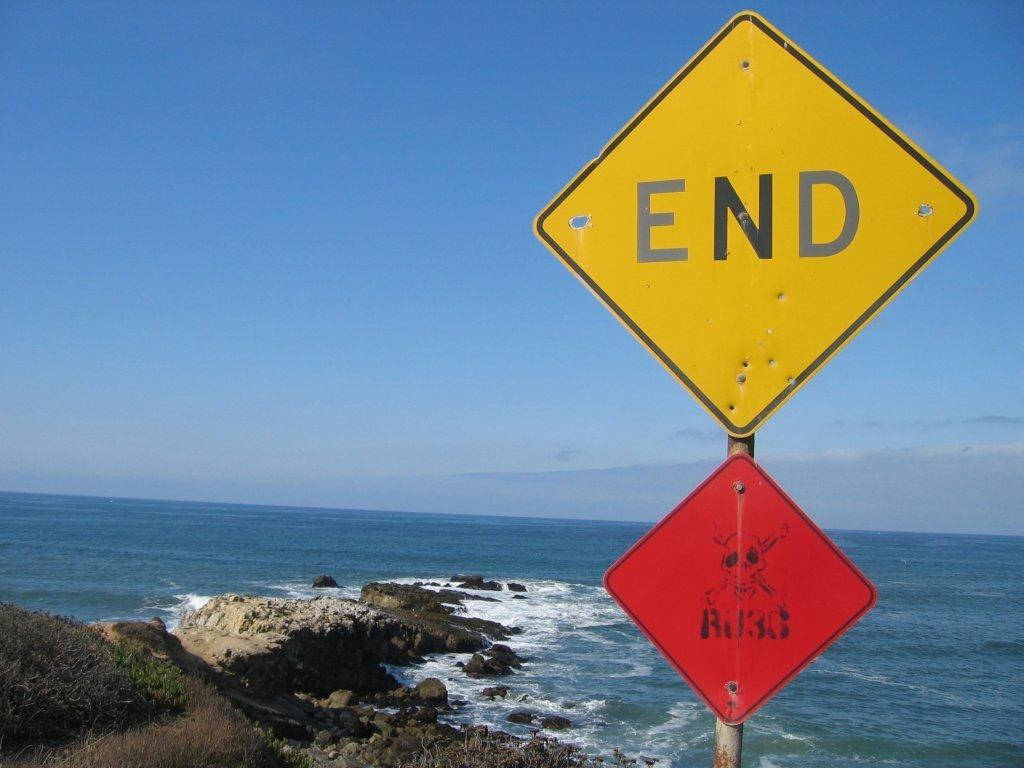<image>
Describe the image concisely. the word end that is on a sign 